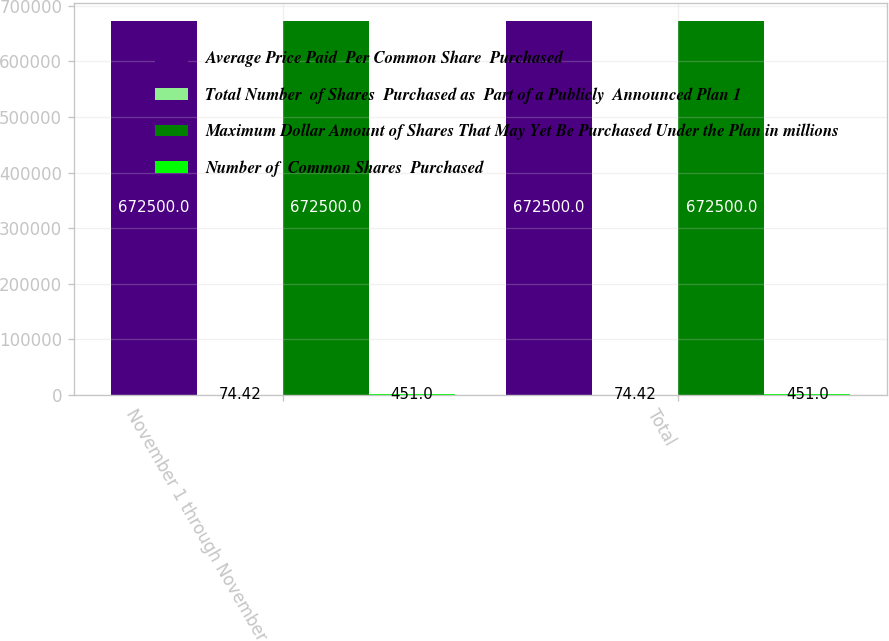Convert chart. <chart><loc_0><loc_0><loc_500><loc_500><stacked_bar_chart><ecel><fcel>November 1 through November 30<fcel>Total<nl><fcel>Average Price Paid  Per Common Share  Purchased<fcel>672500<fcel>672500<nl><fcel>Total Number  of Shares  Purchased as  Part of a Publicly  Announced Plan 1<fcel>74.42<fcel>74.42<nl><fcel>Maximum Dollar Amount of Shares That May Yet Be Purchased Under the Plan in millions<fcel>672500<fcel>672500<nl><fcel>Number of  Common Shares  Purchased<fcel>451<fcel>451<nl></chart> 